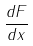Convert formula to latex. <formula><loc_0><loc_0><loc_500><loc_500>\frac { d F } { d x }</formula> 